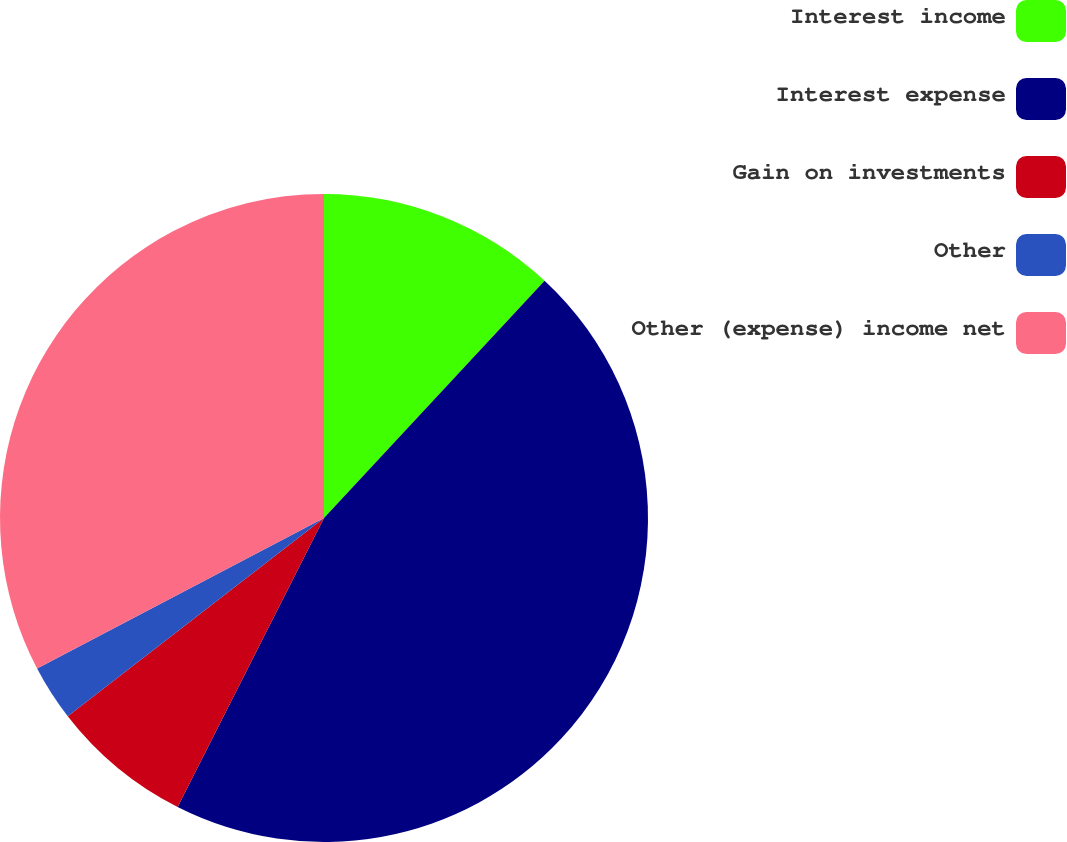<chart> <loc_0><loc_0><loc_500><loc_500><pie_chart><fcel>Interest income<fcel>Interest expense<fcel>Gain on investments<fcel>Other<fcel>Other (expense) income net<nl><fcel>11.92%<fcel>45.54%<fcel>7.06%<fcel>2.79%<fcel>32.69%<nl></chart> 